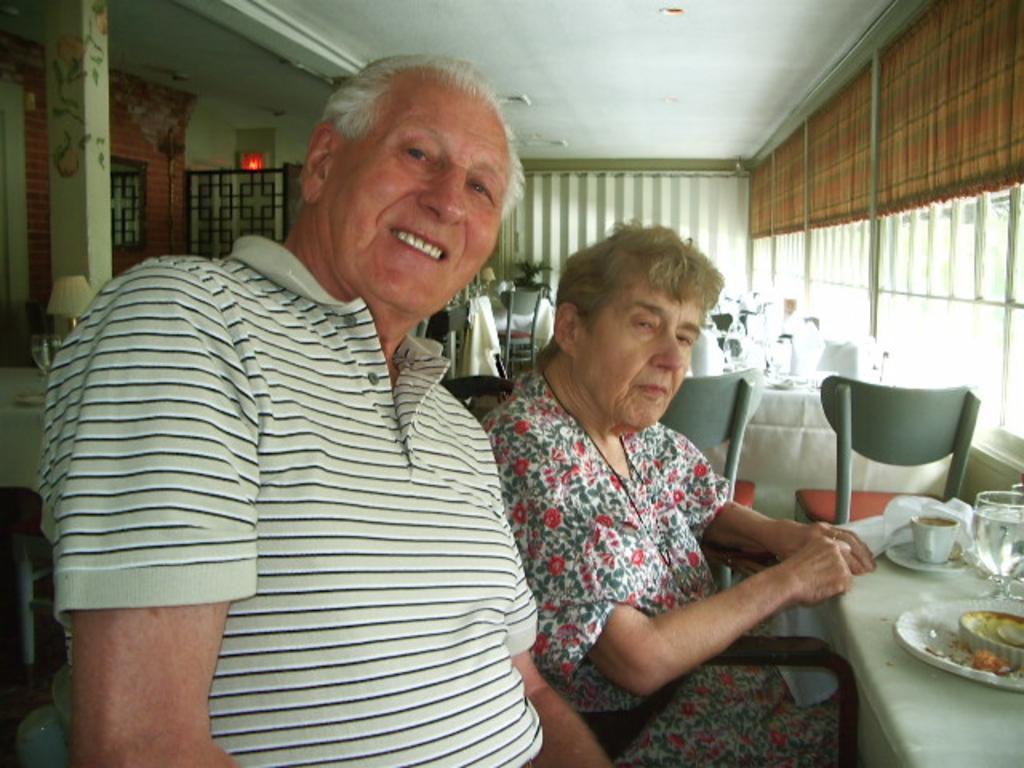Describe this image in one or two sentences. In this image there are two persons old woman is sitting on a chair and the man is having smile in his face in front of them there is a table on that table there is one plate and some food in it and cup with a saucer and a glass filled with water. In the background there are some chairs and table covered with white coloured cloth and gate black colour building and stones red in colour. 